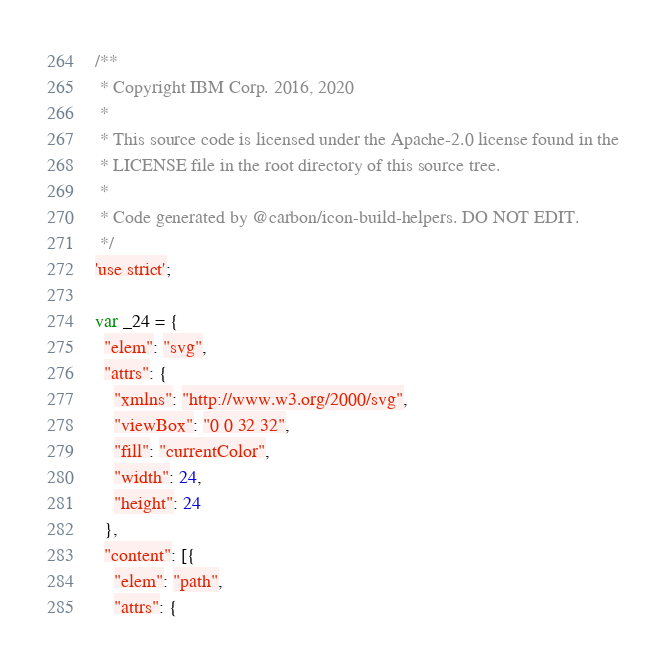Convert code to text. <code><loc_0><loc_0><loc_500><loc_500><_JavaScript_>/**
 * Copyright IBM Corp. 2016, 2020
 *
 * This source code is licensed under the Apache-2.0 license found in the
 * LICENSE file in the root directory of this source tree.
 *
 * Code generated by @carbon/icon-build-helpers. DO NOT EDIT.
 */
'use strict';

var _24 = {
  "elem": "svg",
  "attrs": {
    "xmlns": "http://www.w3.org/2000/svg",
    "viewBox": "0 0 32 32",
    "fill": "currentColor",
    "width": 24,
    "height": 24
  },
  "content": [{
    "elem": "path",
    "attrs": {</code> 